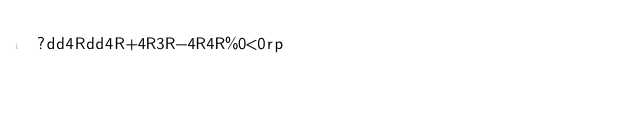<code> <loc_0><loc_0><loc_500><loc_500><_dc_>?dd4Rdd4R+4R3R-4R4R%0<0rp</code> 